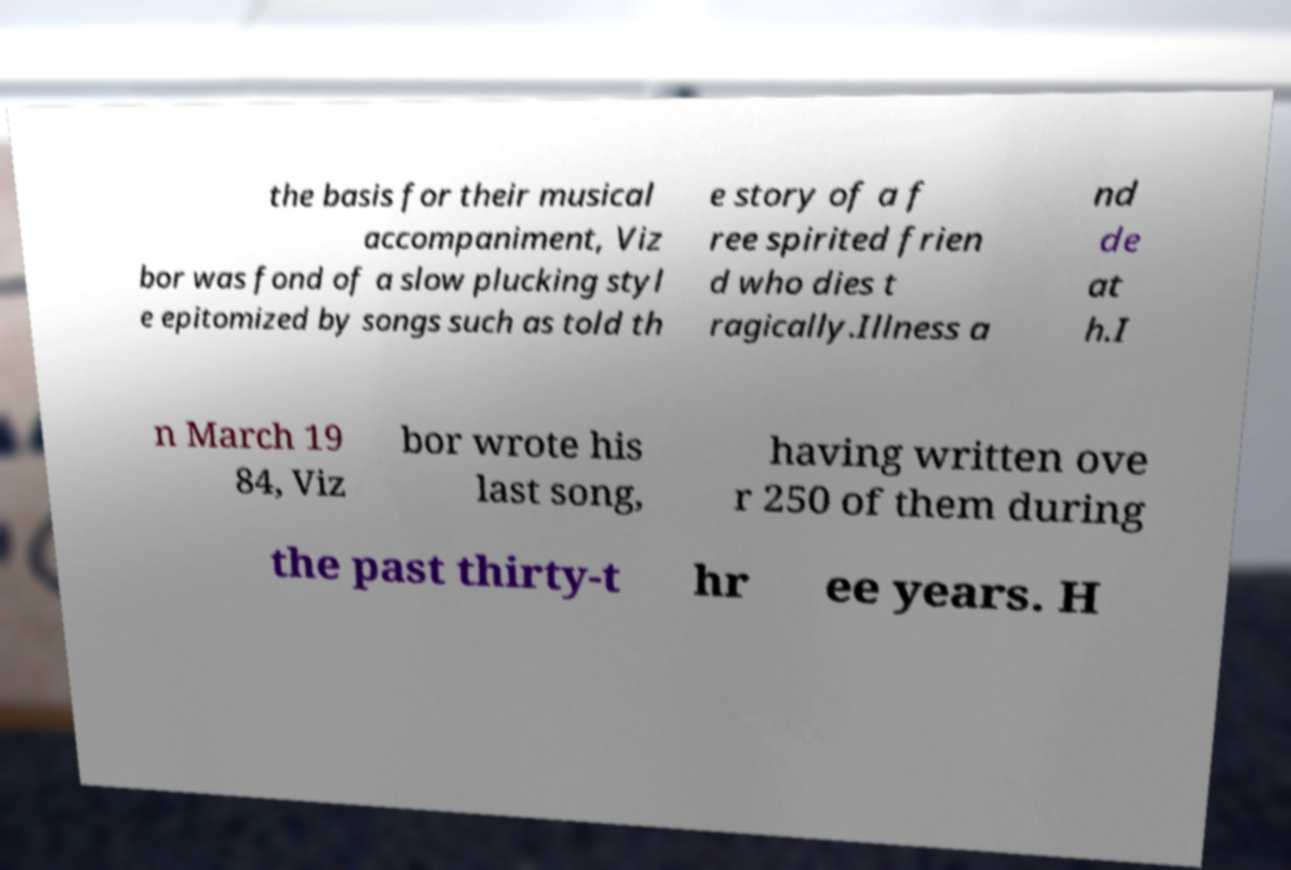What messages or text are displayed in this image? I need them in a readable, typed format. the basis for their musical accompaniment, Viz bor was fond of a slow plucking styl e epitomized by songs such as told th e story of a f ree spirited frien d who dies t ragically.Illness a nd de at h.I n March 19 84, Viz bor wrote his last song, having written ove r 250 of them during the past thirty-t hr ee years. H 